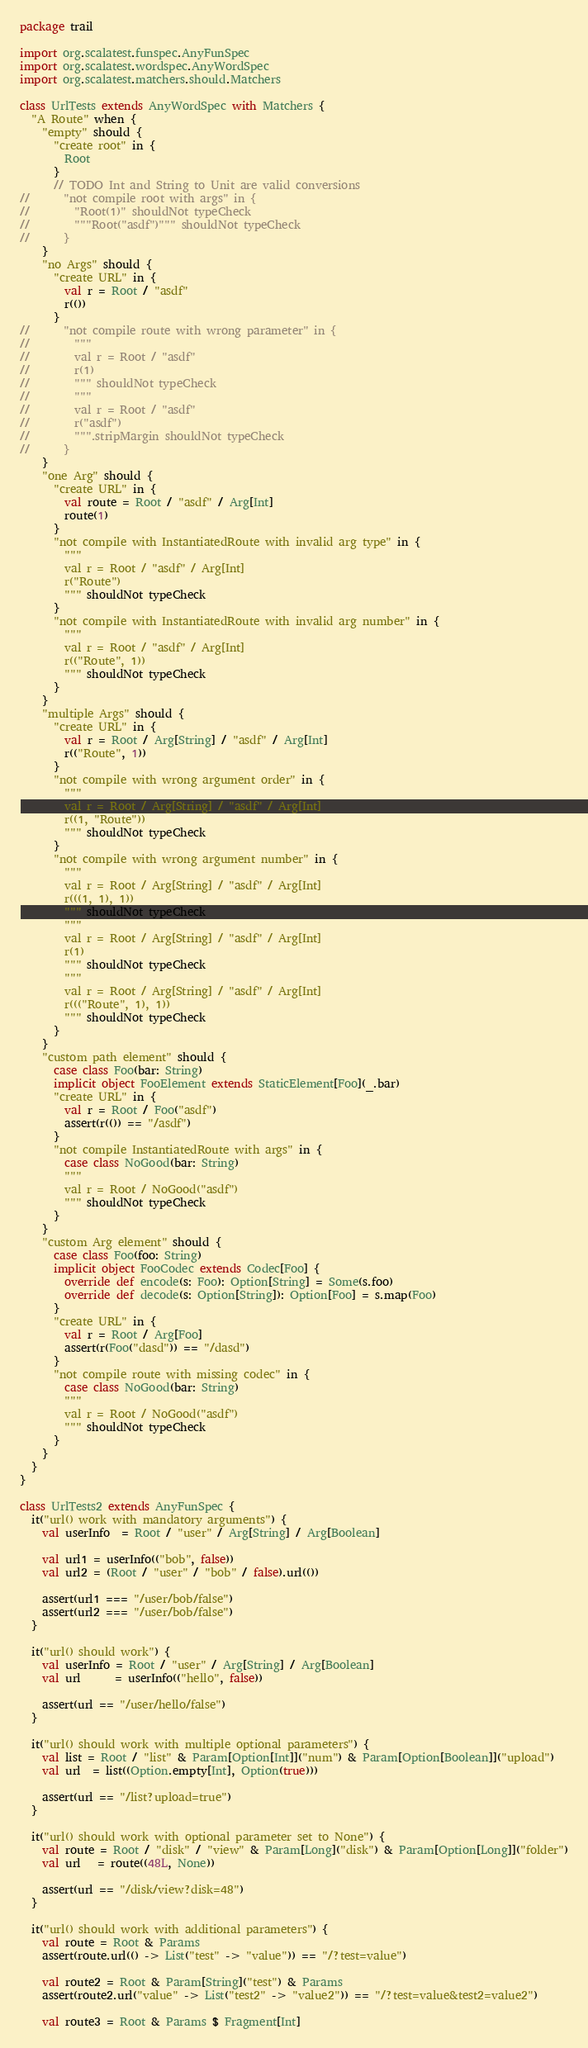<code> <loc_0><loc_0><loc_500><loc_500><_Scala_>package trail

import org.scalatest.funspec.AnyFunSpec
import org.scalatest.wordspec.AnyWordSpec
import org.scalatest.matchers.should.Matchers

class UrlTests extends AnyWordSpec with Matchers {
  "A Route" when {
    "empty" should {
      "create root" in {
        Root
      }
      // TODO Int and String to Unit are valid conversions
//      "not compile root with args" in {
//        "Root(1)" shouldNot typeCheck
//        """Root("asdf")""" shouldNot typeCheck
//      }
    }
    "no Args" should {
      "create URL" in {
        val r = Root / "asdf"
        r(())
      }
//      "not compile route with wrong parameter" in {
//        """
//        val r = Root / "asdf"
//        r(1)
//        """ shouldNot typeCheck
//        """
//        val r = Root / "asdf"
//        r("asdf")
//        """.stripMargin shouldNot typeCheck
//      }
    }
    "one Arg" should {
      "create URL" in {
        val route = Root / "asdf" / Arg[Int]
        route(1)
      }
      "not compile with InstantiatedRoute with invalid arg type" in {
        """
        val r = Root / "asdf" / Arg[Int]
        r("Route")
        """ shouldNot typeCheck
      }
      "not compile with InstantiatedRoute with invalid arg number" in {
        """
        val r = Root / "asdf" / Arg[Int]
        r(("Route", 1))
        """ shouldNot typeCheck
      }
    }
    "multiple Args" should {
      "create URL" in {
        val r = Root / Arg[String] / "asdf" / Arg[Int]
        r(("Route", 1))
      }
      "not compile with wrong argument order" in {
        """
        val r = Root / Arg[String] / "asdf" / Arg[Int]
        r((1, "Route"))
        """ shouldNot typeCheck
      }
      "not compile with wrong argument number" in {
        """
        val r = Root / Arg[String] / "asdf" / Arg[Int]
        r(((1, 1), 1))
        """ shouldNot typeCheck
        """
        val r = Root / Arg[String] / "asdf" / Arg[Int]
        r(1)
        """ shouldNot typeCheck
        """
        val r = Root / Arg[String] / "asdf" / Arg[Int]
        r((("Route", 1), 1))
        """ shouldNot typeCheck
      }
    }
    "custom path element" should {
      case class Foo(bar: String)
      implicit object FooElement extends StaticElement[Foo](_.bar)
      "create URL" in {
        val r = Root / Foo("asdf")
        assert(r(()) == "/asdf")
      }
      "not compile InstantiatedRoute with args" in {
        case class NoGood(bar: String)
        """
        val r = Root / NoGood("asdf")
        """ shouldNot typeCheck
      }
    }
    "custom Arg element" should {
      case class Foo(foo: String)
      implicit object FooCodec extends Codec[Foo] {
        override def encode(s: Foo): Option[String] = Some(s.foo)
        override def decode(s: Option[String]): Option[Foo] = s.map(Foo)
      }
      "create URL" in {
        val r = Root / Arg[Foo]
        assert(r(Foo("dasd")) == "/dasd")
      }
      "not compile route with missing codec" in {
        case class NoGood(bar: String)
        """
        val r = Root / NoGood("asdf")
        """ shouldNot typeCheck
      }
    }
  }
}

class UrlTests2 extends AnyFunSpec {
  it("url() work with mandatory arguments") {
    val userInfo  = Root / "user" / Arg[String] / Arg[Boolean]

    val url1 = userInfo(("bob", false))
    val url2 = (Root / "user" / "bob" / false).url(())

    assert(url1 === "/user/bob/false")
    assert(url2 === "/user/bob/false")
  }

  it("url() should work") {
    val userInfo = Root / "user" / Arg[String] / Arg[Boolean]
    val url      = userInfo(("hello", false))

    assert(url == "/user/hello/false")
  }

  it("url() should work with multiple optional parameters") {
    val list = Root / "list" & Param[Option[Int]]("num") & Param[Option[Boolean]]("upload")
    val url  = list((Option.empty[Int], Option(true)))

    assert(url == "/list?upload=true")
  }

  it("url() should work with optional parameter set to None") {
    val route = Root / "disk" / "view" & Param[Long]("disk") & Param[Option[Long]]("folder")
    val url   = route((48L, None))

    assert(url == "/disk/view?disk=48")
  }

  it("url() should work with additional parameters") {
    val route = Root & Params
    assert(route.url(() -> List("test" -> "value")) == "/?test=value")

    val route2 = Root & Param[String]("test") & Params
    assert(route2.url("value" -> List("test2" -> "value2")) == "/?test=value&test2=value2")

    val route3 = Root & Params $ Fragment[Int]</code> 